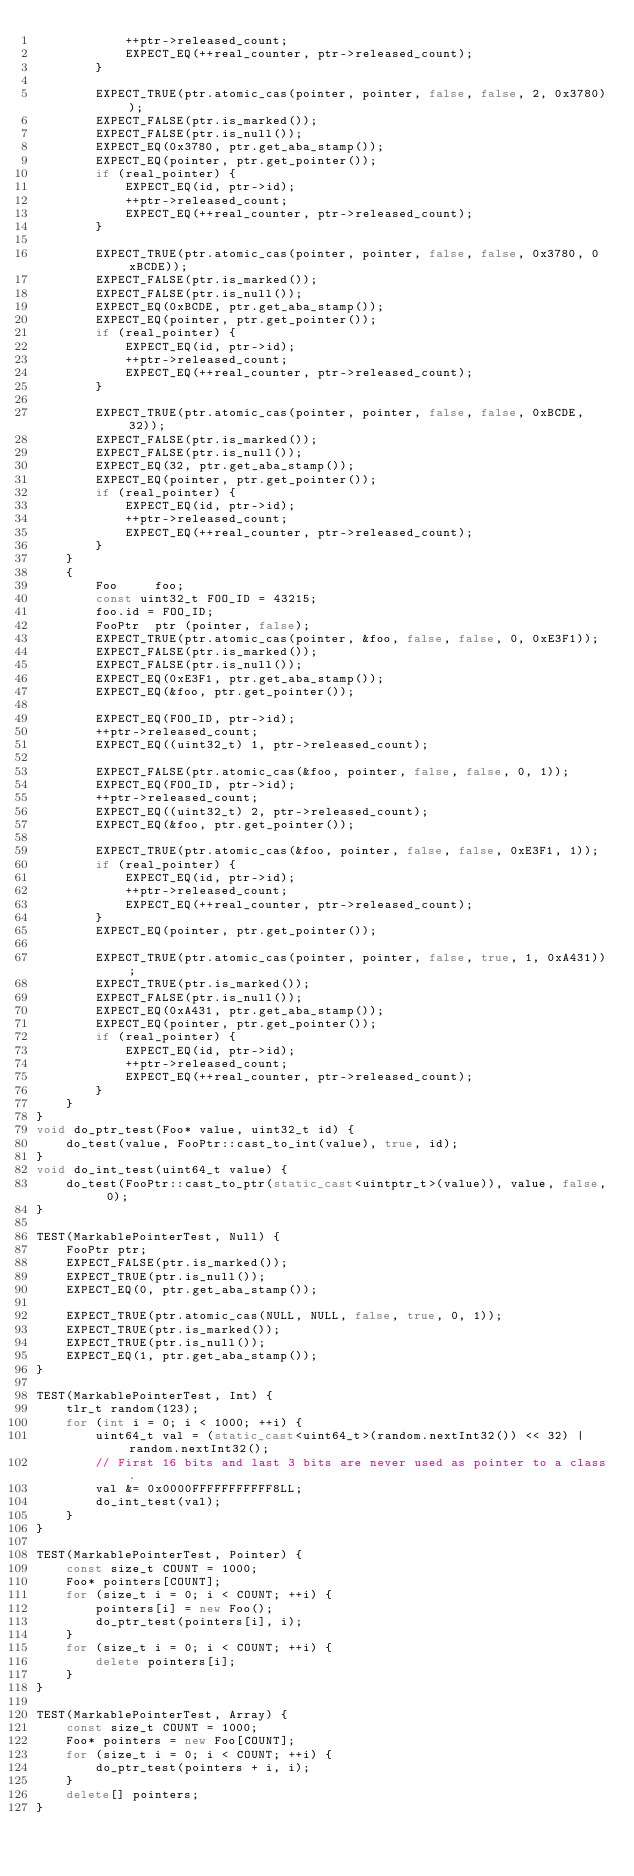<code> <loc_0><loc_0><loc_500><loc_500><_C++_>            ++ptr->released_count;
            EXPECT_EQ(++real_counter, ptr->released_count);
        }

        EXPECT_TRUE(ptr.atomic_cas(pointer, pointer, false, false, 2, 0x3780));
        EXPECT_FALSE(ptr.is_marked());
        EXPECT_FALSE(ptr.is_null());
        EXPECT_EQ(0x3780, ptr.get_aba_stamp());
        EXPECT_EQ(pointer, ptr.get_pointer());
        if (real_pointer) {
            EXPECT_EQ(id, ptr->id);
            ++ptr->released_count;
            EXPECT_EQ(++real_counter, ptr->released_count);
        }

        EXPECT_TRUE(ptr.atomic_cas(pointer, pointer, false, false, 0x3780, 0xBCDE));
        EXPECT_FALSE(ptr.is_marked());
        EXPECT_FALSE(ptr.is_null());
        EXPECT_EQ(0xBCDE, ptr.get_aba_stamp());
        EXPECT_EQ(pointer, ptr.get_pointer());
        if (real_pointer) {
            EXPECT_EQ(id, ptr->id);
            ++ptr->released_count;
            EXPECT_EQ(++real_counter, ptr->released_count);
        }

        EXPECT_TRUE(ptr.atomic_cas(pointer, pointer, false, false, 0xBCDE, 32));
        EXPECT_FALSE(ptr.is_marked());
        EXPECT_FALSE(ptr.is_null());
        EXPECT_EQ(32, ptr.get_aba_stamp());
        EXPECT_EQ(pointer, ptr.get_pointer());
        if (real_pointer) {
            EXPECT_EQ(id, ptr->id);
            ++ptr->released_count;
            EXPECT_EQ(++real_counter, ptr->released_count);
        }
    }
    {
        Foo     foo;
        const uint32_t FOO_ID = 43215;
        foo.id = FOO_ID;
        FooPtr  ptr (pointer, false);
        EXPECT_TRUE(ptr.atomic_cas(pointer, &foo, false, false, 0, 0xE3F1));
        EXPECT_FALSE(ptr.is_marked());
        EXPECT_FALSE(ptr.is_null());
        EXPECT_EQ(0xE3F1, ptr.get_aba_stamp());
        EXPECT_EQ(&foo, ptr.get_pointer());

        EXPECT_EQ(FOO_ID, ptr->id);
        ++ptr->released_count;
        EXPECT_EQ((uint32_t) 1, ptr->released_count);

        EXPECT_FALSE(ptr.atomic_cas(&foo, pointer, false, false, 0, 1));
        EXPECT_EQ(FOO_ID, ptr->id);
        ++ptr->released_count;
        EXPECT_EQ((uint32_t) 2, ptr->released_count);
        EXPECT_EQ(&foo, ptr.get_pointer());

        EXPECT_TRUE(ptr.atomic_cas(&foo, pointer, false, false, 0xE3F1, 1));
        if (real_pointer) {
            EXPECT_EQ(id, ptr->id);
            ++ptr->released_count;
            EXPECT_EQ(++real_counter, ptr->released_count);
        }
        EXPECT_EQ(pointer, ptr.get_pointer());

        EXPECT_TRUE(ptr.atomic_cas(pointer, pointer, false, true, 1, 0xA431));
        EXPECT_TRUE(ptr.is_marked());
        EXPECT_FALSE(ptr.is_null());
        EXPECT_EQ(0xA431, ptr.get_aba_stamp());
        EXPECT_EQ(pointer, ptr.get_pointer());
        if (real_pointer) {
            EXPECT_EQ(id, ptr->id);
            ++ptr->released_count;
            EXPECT_EQ(++real_counter, ptr->released_count);
        }
    }
}
void do_ptr_test(Foo* value, uint32_t id) {
    do_test(value, FooPtr::cast_to_int(value), true, id);
}
void do_int_test(uint64_t value) {
    do_test(FooPtr::cast_to_ptr(static_cast<uintptr_t>(value)), value, false, 0);
}

TEST(MarkablePointerTest, Null) {
    FooPtr ptr;
    EXPECT_FALSE(ptr.is_marked());
    EXPECT_TRUE(ptr.is_null());
    EXPECT_EQ(0, ptr.get_aba_stamp());

    EXPECT_TRUE(ptr.atomic_cas(NULL, NULL, false, true, 0, 1));
    EXPECT_TRUE(ptr.is_marked());
    EXPECT_TRUE(ptr.is_null());
    EXPECT_EQ(1, ptr.get_aba_stamp());
}

TEST(MarkablePointerTest, Int) {
    tlr_t random(123);
    for (int i = 0; i < 1000; ++i) {
        uint64_t val = (static_cast<uint64_t>(random.nextInt32()) << 32) | random.nextInt32();
        // First 16 bits and last 3 bits are never used as pointer to a class.
        val &= 0x0000FFFFFFFFFFF8LL;
        do_int_test(val);
    }
}

TEST(MarkablePointerTest, Pointer) {
    const size_t COUNT = 1000;
    Foo* pointers[COUNT];
    for (size_t i = 0; i < COUNT; ++i) {
        pointers[i] = new Foo();
        do_ptr_test(pointers[i], i);
    }
    for (size_t i = 0; i < COUNT; ++i) {
        delete pointers[i];
    }
}

TEST(MarkablePointerTest, Array) {
    const size_t COUNT = 1000;
    Foo* pointers = new Foo[COUNT];
    for (size_t i = 0; i < COUNT; ++i) {
        do_ptr_test(pointers + i, i);
    }
    delete[] pointers;
}
</code> 